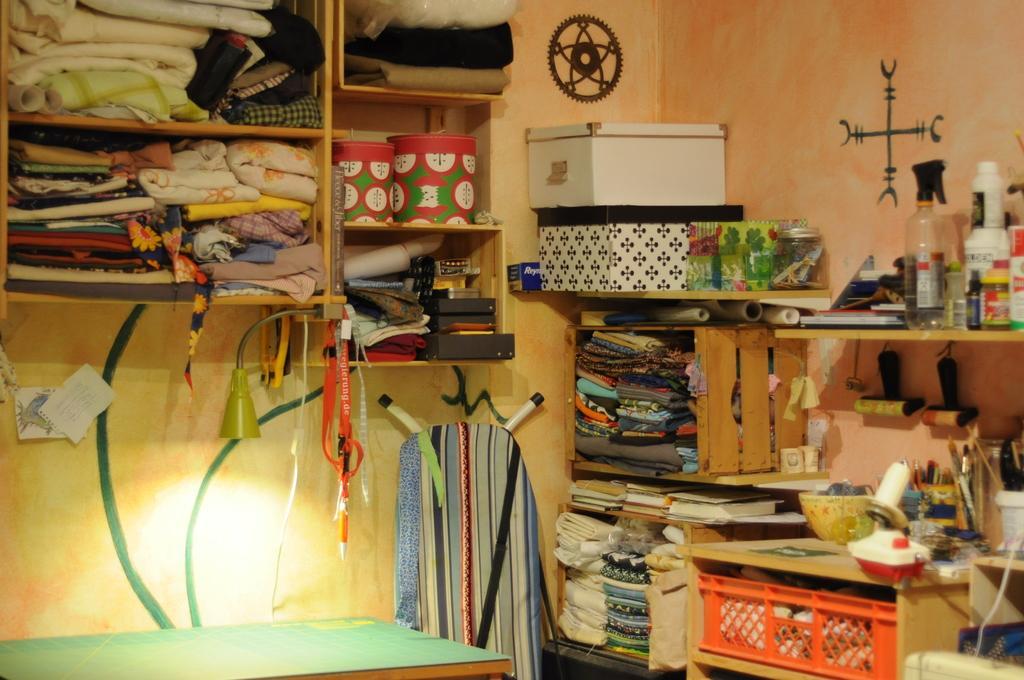How would you summarize this image in a sentence or two? In this image there are few clothes and some other objects are arranged in a wooden rack and some ribbons and id-cards are hanging from the rack, below the rack there is a table and a lamp, beside the table there is an object and above the table there are two papers attached to the wall. On the other side of the image there are few clothes and other objects arranged in a rack. In the background there is a wall. 